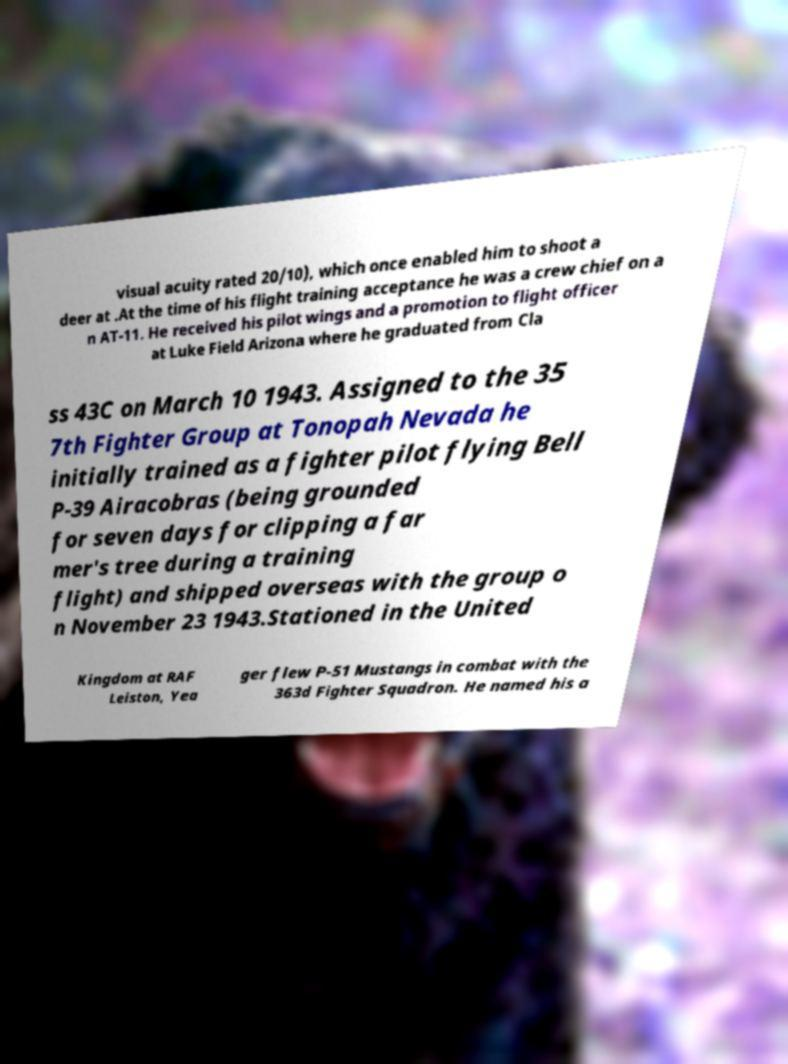Please read and relay the text visible in this image. What does it say? visual acuity rated 20/10), which once enabled him to shoot a deer at .At the time of his flight training acceptance he was a crew chief on a n AT-11. He received his pilot wings and a promotion to flight officer at Luke Field Arizona where he graduated from Cla ss 43C on March 10 1943. Assigned to the 35 7th Fighter Group at Tonopah Nevada he initially trained as a fighter pilot flying Bell P-39 Airacobras (being grounded for seven days for clipping a far mer's tree during a training flight) and shipped overseas with the group o n November 23 1943.Stationed in the United Kingdom at RAF Leiston, Yea ger flew P-51 Mustangs in combat with the 363d Fighter Squadron. He named his a 